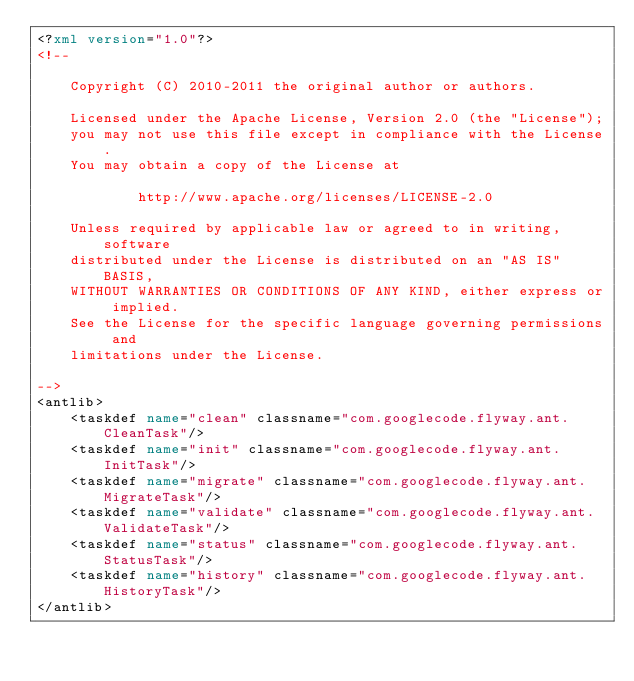Convert code to text. <code><loc_0><loc_0><loc_500><loc_500><_XML_><?xml version="1.0"?>
<!--

    Copyright (C) 2010-2011 the original author or authors.

    Licensed under the Apache License, Version 2.0 (the "License");
    you may not use this file except in compliance with the License.
    You may obtain a copy of the License at

            http://www.apache.org/licenses/LICENSE-2.0

    Unless required by applicable law or agreed to in writing, software
    distributed under the License is distributed on an "AS IS" BASIS,
    WITHOUT WARRANTIES OR CONDITIONS OF ANY KIND, either express or implied.
    See the License for the specific language governing permissions and
    limitations under the License.

-->
<antlib>
    <taskdef name="clean" classname="com.googlecode.flyway.ant.CleanTask"/>
    <taskdef name="init" classname="com.googlecode.flyway.ant.InitTask"/>
    <taskdef name="migrate" classname="com.googlecode.flyway.ant.MigrateTask"/>
    <taskdef name="validate" classname="com.googlecode.flyway.ant.ValidateTask"/>
    <taskdef name="status" classname="com.googlecode.flyway.ant.StatusTask"/>
    <taskdef name="history" classname="com.googlecode.flyway.ant.HistoryTask"/>
</antlib></code> 